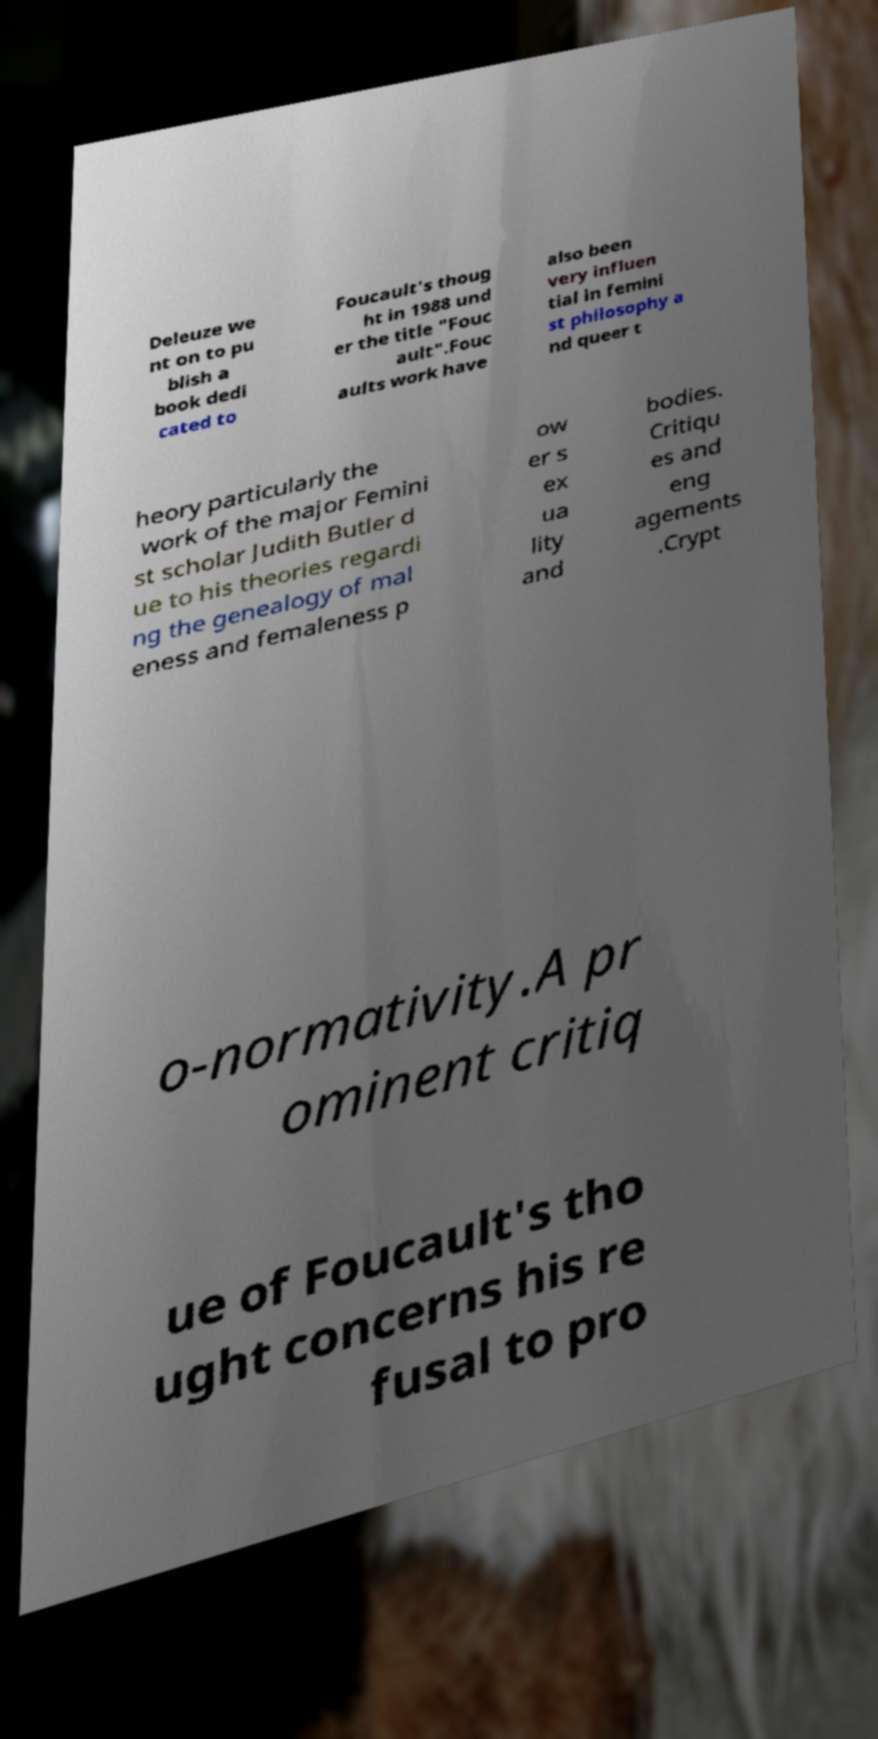Could you assist in decoding the text presented in this image and type it out clearly? Deleuze we nt on to pu blish a book dedi cated to Foucault's thoug ht in 1988 und er the title "Fouc ault".Fouc aults work have also been very influen tial in femini st philosophy a nd queer t heory particularly the work of the major Femini st scholar Judith Butler d ue to his theories regardi ng the genealogy of mal eness and femaleness p ow er s ex ua lity and bodies. Critiqu es and eng agements .Crypt o-normativity.A pr ominent critiq ue of Foucault's tho ught concerns his re fusal to pro 